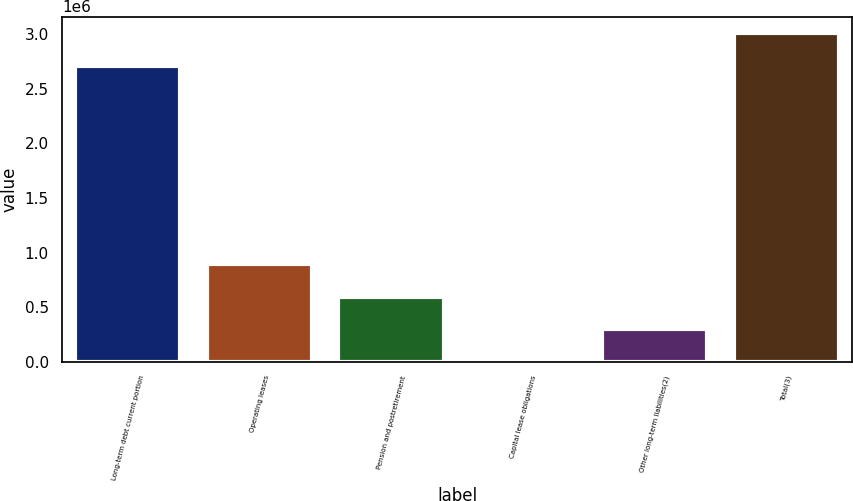Convert chart to OTSL. <chart><loc_0><loc_0><loc_500><loc_500><bar_chart><fcel>Long-term debt current portion<fcel>Operating leases<fcel>Pension and postretirement<fcel>Capital lease obligations<fcel>Other long-term liabilities(2)<fcel>Total(3)<nl><fcel>2.71457e+06<fcel>894519<fcel>596356<fcel>31<fcel>298194<fcel>3.01273e+06<nl></chart> 